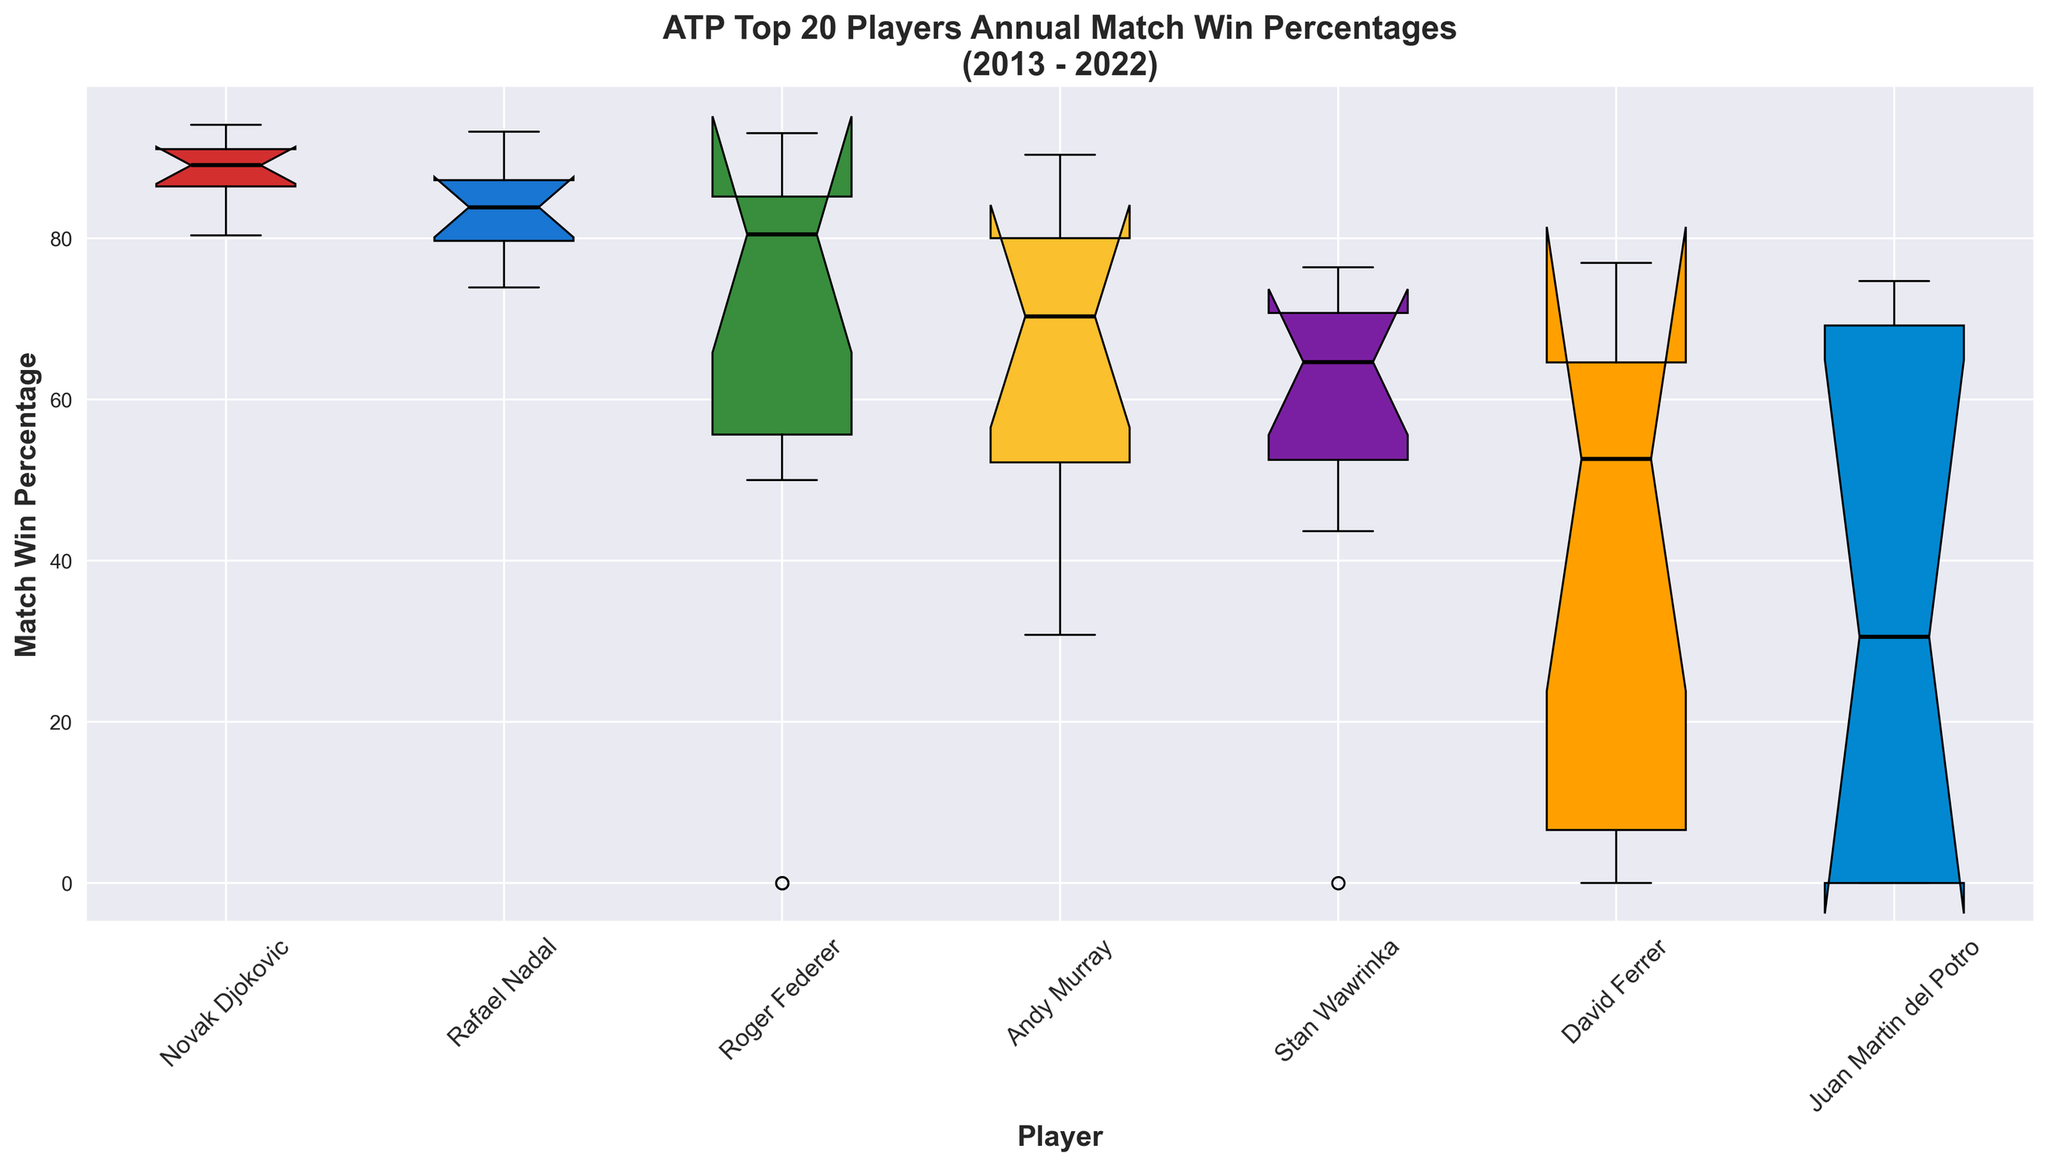How does Rafael Nadal’s median annual match win percentage compare to Novak Djokovic’s? To find the median match win percentages of Rafael Nadal and Novak Djokovic, look at the line in the middle of the boxes for each player. Compare the positions of the two lines relative to each other.
Answer: Nadal's is lower than Djokovic's Which player has the highest median annual match win percentage over the last decade? Identify the position of the medians (the lines inside the boxes) for all the players and find the one that's highest on the y-axis.
Answer: Novak Djokovic What is the general trend for Roger Federer’s annual match win percentage from 2013 to 2022? Check the changes in position and shape of the boxes for Roger Federer from left to right, noting any consistent movements up or down or variability changes.
Answer: Decreasing Between Andy Murray and Stan Wawrinka, who has a greater variability in match win percentage? Evaluate the height of the boxes and whiskers for Andy Murray and Stan Wawrinka. Greater height indicates more variability.
Answer: Andy Murray Did any player have a year with a zero match win percentage? Look for any outlier points or near-zero values for any player in the boxes. Three players have zero match win percentage in selected years like Roger Federer in 2020 & 2022; David Ferrer in 2019, 2020, & 2021; Juan Martin del Potro in 2014, 2015, 2020, 2021, & 2022.
Answer: Yes Which player has the most consistent performance based on the interquartile range (IQR) over the last decade? The most consistent player will have the smallest IQR (the height of the box that represents the middle 50% of the data). Identify the player with the smallest box height.
Answer: Novak Djokovic Does Rafael Nadal have any years with match win percentages below 80%? Check the position of the lowest values (the bottom of the boxes and whiskers) for Rafael Nadal to see if any drop below 80%.
Answer: Yes Which player had the lowest median match win percentage? Find the median lines for all players and identify the one that is lowest on the y-axis.
Answer: Stan Wawrinka How does the variability in match win percentages for Novak Djokovic compare to other players? Assess the height of Novak Djokovic's box and whiskers in relation to those of the other players. Higher variability will correspond to taller boxes and whiskers.
Answer: Less variable Is there a noticeable difference in match win percentages before and after 2017 for Andy Murray? Compare the boxes for Andy Murray before and after the 2017 mark. Look for shifts in position and changes in variability.
Answer: Yes 